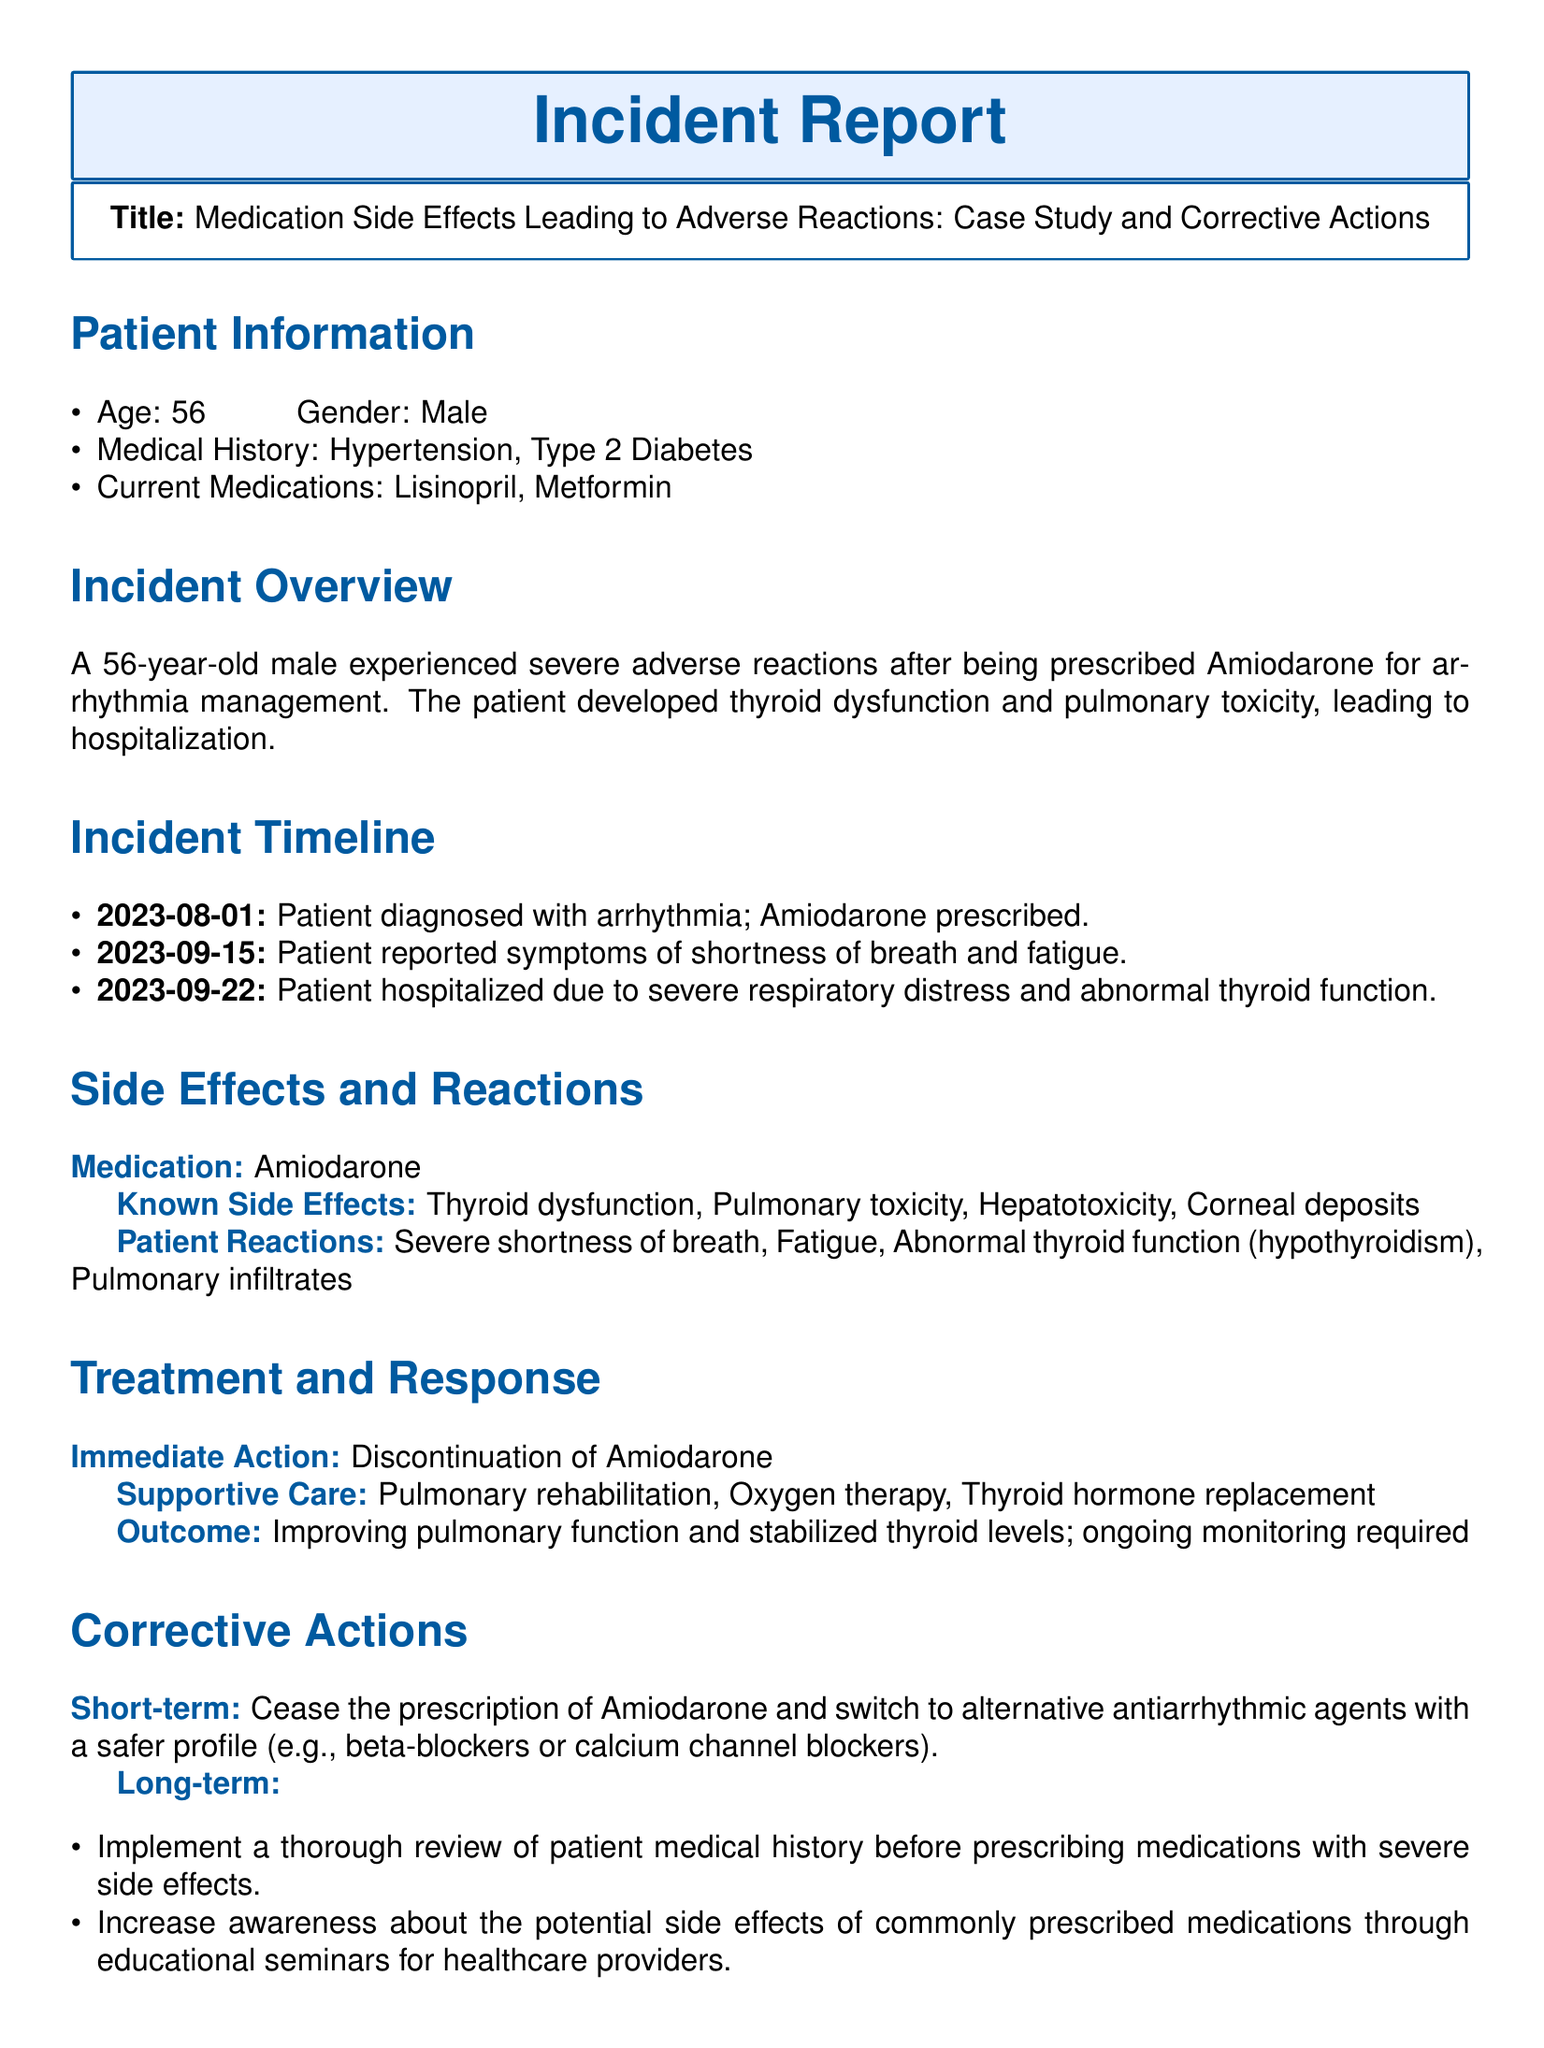What is the patient's age? The patient's age is mentioned explicitly under the patient information section of the document.
Answer: 56 What was the prescribed medication for the patient? The prescribed medication for the patient is stated in the incident overview section.
Answer: Amiodarone What side effect did the patient experience that relates to respiratory issues? The side effect relating to respiratory issues is detailed in the side effects and reactions section.
Answer: Pulmonary toxicity When did the patient report symptoms of shortness of breath? The exact date the patient reported symptoms is specified in the incident timeline section.
Answer: 2023-09-15 What immediate action was taken in response to the adverse reaction? The immediate action taken is outlined in the treatment and response section of the report.
Answer: Discontinuation of Amiodarone What long-term corrective action involves increasing healthcare providers' awareness? The long-term corrective action related to awareness is described clearly in the corrective actions section.
Answer: Increase awareness about the potential side effects How many references are listed in the evidence section? The number of references is counted in the evidence references section of the document.
Answer: 2 